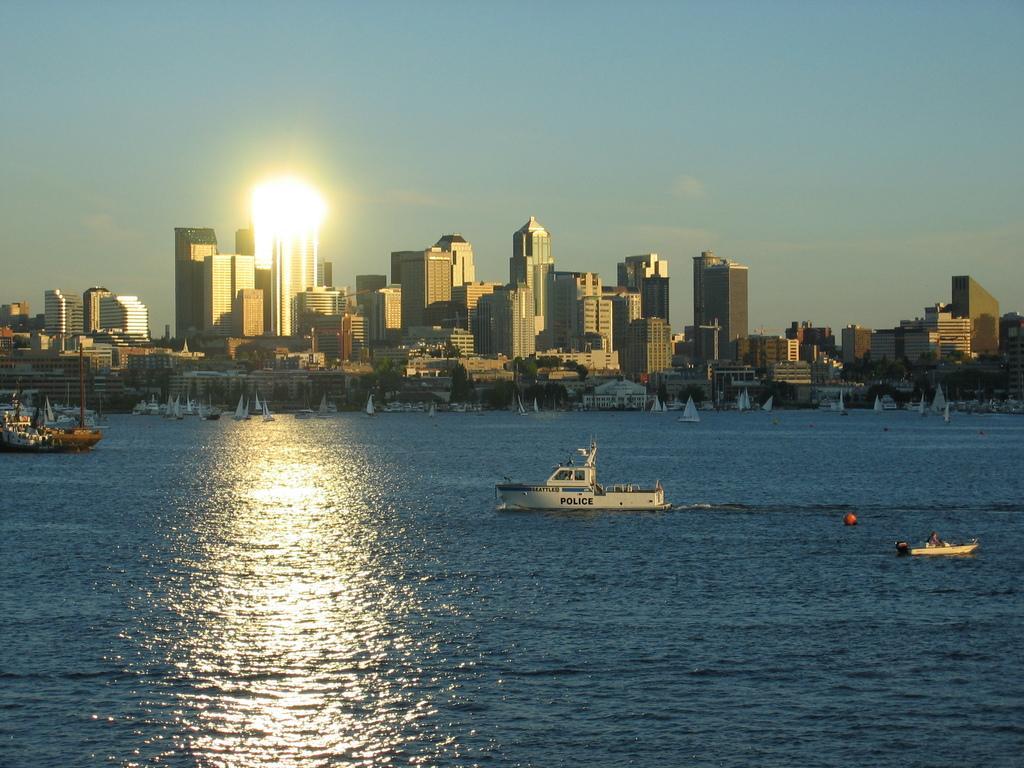Please provide a concise description of this image. In this image we can see the boats in the water. And we can see the many buildings. And we can see some light reflections. And we can see the clouds in the sky. 